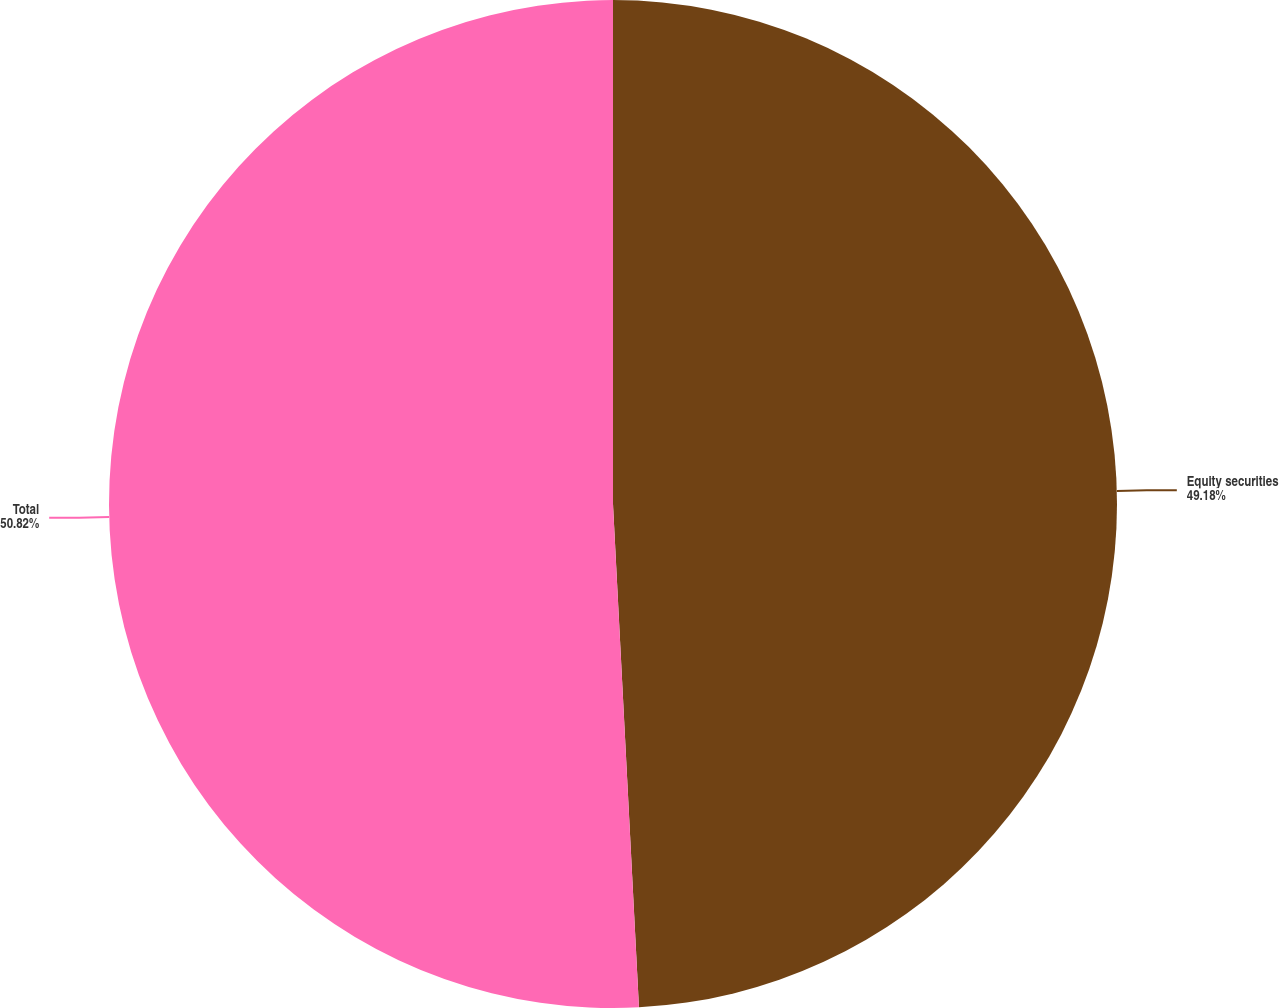Convert chart to OTSL. <chart><loc_0><loc_0><loc_500><loc_500><pie_chart><fcel>Equity securities<fcel>Total<nl><fcel>49.18%<fcel>50.82%<nl></chart> 